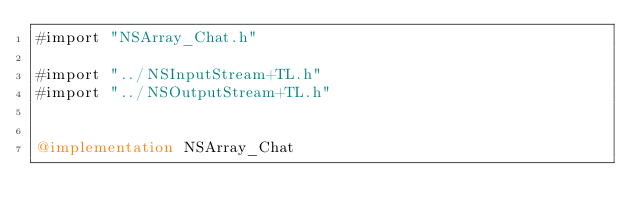<code> <loc_0><loc_0><loc_500><loc_500><_ObjectiveC_>#import "NSArray_Chat.h"

#import "../NSInputStream+TL.h"
#import "../NSOutputStream+TL.h"


@implementation NSArray_Chat

</code> 